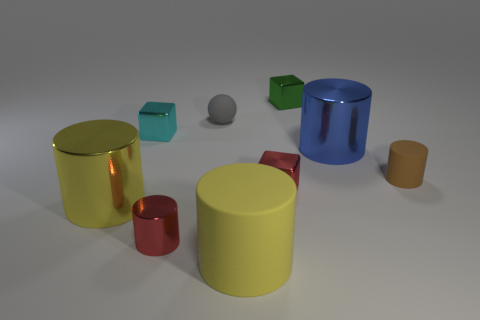What is the color of the rubber ball?
Your answer should be compact. Gray. There is a small brown matte object; are there any big yellow rubber cylinders behind it?
Keep it short and to the point. No. Is the color of the ball the same as the big matte cylinder?
Your answer should be very brief. No. What number of shiny objects are the same color as the tiny metal cylinder?
Make the answer very short. 1. There is a cube in front of the big metal thing behind the small brown thing; how big is it?
Provide a succinct answer. Small. The green metal object is what shape?
Give a very brief answer. Cube. What is the material of the tiny object that is right of the green cube?
Your answer should be very brief. Rubber. What is the color of the big metallic cylinder that is in front of the big metal thing behind the object that is on the left side of the cyan metal block?
Provide a succinct answer. Yellow. What is the color of the matte cylinder that is the same size as the gray rubber object?
Provide a succinct answer. Brown. What number of metal things are either yellow things or tiny gray spheres?
Your answer should be compact. 1. 